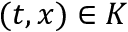<formula> <loc_0><loc_0><loc_500><loc_500>( t , x ) \in K</formula> 